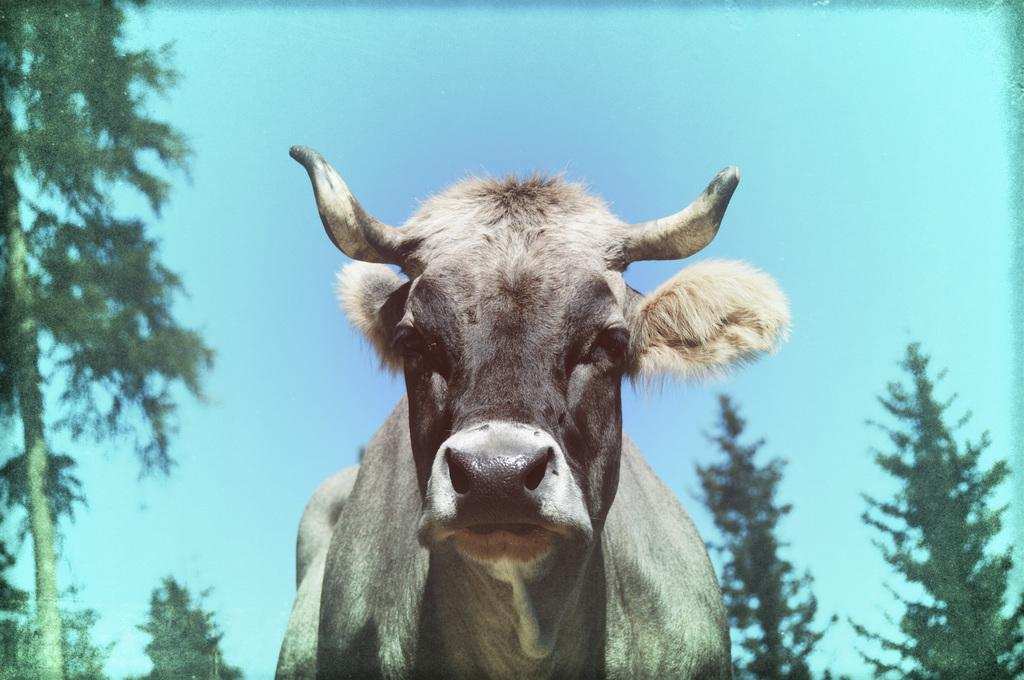What type of animal is in the image? The type of animal cannot be determined from the provided facts. What can be seen in the background of the image? There are trees and the sky visible in the background of the image. What type of grain is being stored in the jail in the image? There is no grain or jail present in the image. 